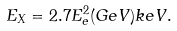<formula> <loc_0><loc_0><loc_500><loc_500>E _ { X } = 2 . 7 E _ { e } ^ { 2 } ( G e V ) k e V .</formula> 